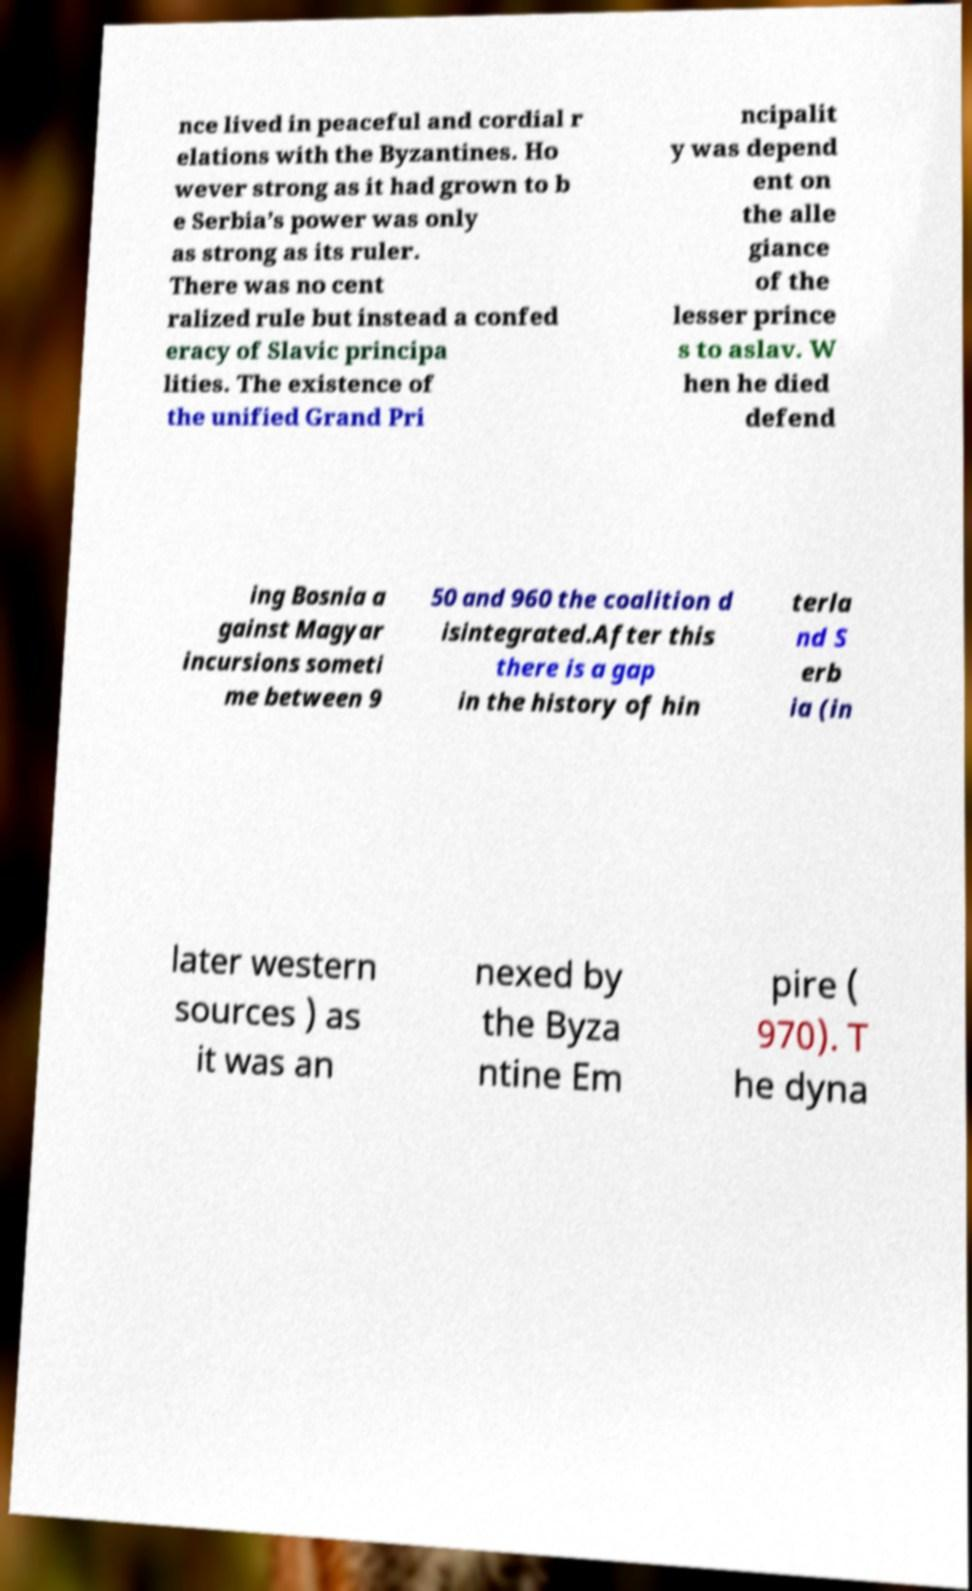I need the written content from this picture converted into text. Can you do that? nce lived in peaceful and cordial r elations with the Byzantines. Ho wever strong as it had grown to b e Serbia’s power was only as strong as its ruler. There was no cent ralized rule but instead a confed eracy of Slavic principa lities. The existence of the unified Grand Pri ncipalit y was depend ent on the alle giance of the lesser prince s to aslav. W hen he died defend ing Bosnia a gainst Magyar incursions someti me between 9 50 and 960 the coalition d isintegrated.After this there is a gap in the history of hin terla nd S erb ia (in later western sources ) as it was an nexed by the Byza ntine Em pire ( 970). T he dyna 